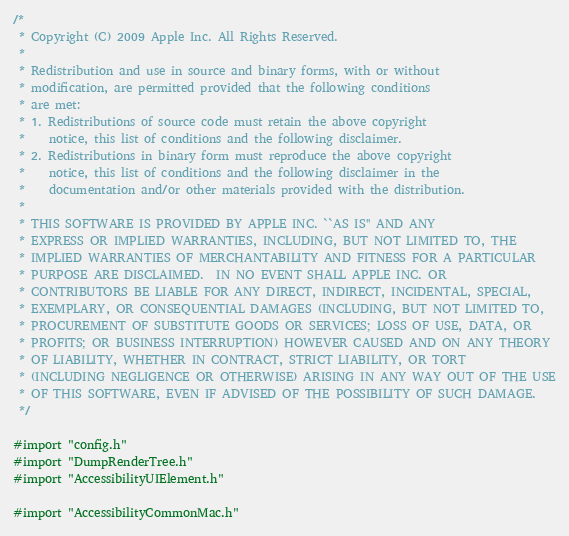Convert code to text. <code><loc_0><loc_0><loc_500><loc_500><_ObjectiveC_>/*
 * Copyright (C) 2009 Apple Inc. All Rights Reserved.
 *
 * Redistribution and use in source and binary forms, with or without
 * modification, are permitted provided that the following conditions
 * are met:
 * 1. Redistributions of source code must retain the above copyright
 *    notice, this list of conditions and the following disclaimer.
 * 2. Redistributions in binary form must reproduce the above copyright
 *    notice, this list of conditions and the following disclaimer in the
 *    documentation and/or other materials provided with the distribution.
 *
 * THIS SOFTWARE IS PROVIDED BY APPLE INC. ``AS IS'' AND ANY
 * EXPRESS OR IMPLIED WARRANTIES, INCLUDING, BUT NOT LIMITED TO, THE
 * IMPLIED WARRANTIES OF MERCHANTABILITY AND FITNESS FOR A PARTICULAR
 * PURPOSE ARE DISCLAIMED.  IN NO EVENT SHALL APPLE INC. OR
 * CONTRIBUTORS BE LIABLE FOR ANY DIRECT, INDIRECT, INCIDENTAL, SPECIAL,
 * EXEMPLARY, OR CONSEQUENTIAL DAMAGES (INCLUDING, BUT NOT LIMITED TO,
 * PROCUREMENT OF SUBSTITUTE GOODS OR SERVICES; LOSS OF USE, DATA, OR
 * PROFITS; OR BUSINESS INTERRUPTION) HOWEVER CAUSED AND ON ANY THEORY
 * OF LIABILITY, WHETHER IN CONTRACT, STRICT LIABILITY, OR TORT
 * (INCLUDING NEGLIGENCE OR OTHERWISE) ARISING IN ANY WAY OUT OF THE USE
 * OF THIS SOFTWARE, EVEN IF ADVISED OF THE POSSIBILITY OF SUCH DAMAGE. 
 */

#import "config.h"
#import "DumpRenderTree.h"
#import "AccessibilityUIElement.h"

#import "AccessibilityCommonMac.h"</code> 